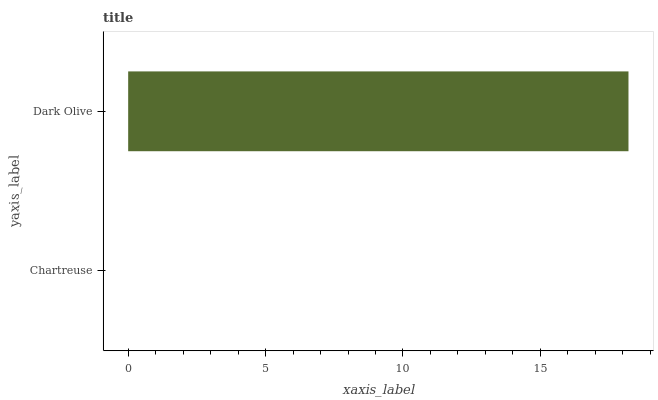Is Chartreuse the minimum?
Answer yes or no. Yes. Is Dark Olive the maximum?
Answer yes or no. Yes. Is Dark Olive the minimum?
Answer yes or no. No. Is Dark Olive greater than Chartreuse?
Answer yes or no. Yes. Is Chartreuse less than Dark Olive?
Answer yes or no. Yes. Is Chartreuse greater than Dark Olive?
Answer yes or no. No. Is Dark Olive less than Chartreuse?
Answer yes or no. No. Is Dark Olive the high median?
Answer yes or no. Yes. Is Chartreuse the low median?
Answer yes or no. Yes. Is Chartreuse the high median?
Answer yes or no. No. Is Dark Olive the low median?
Answer yes or no. No. 